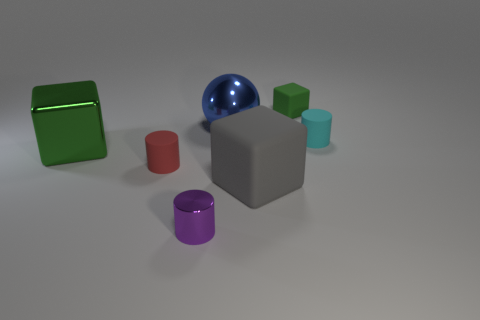There is a small red object that is made of the same material as the small green thing; what shape is it? The small red object shares its cylindrical shape with the small green item, suggesting that these two items are likely part of a set designed in harmony. 